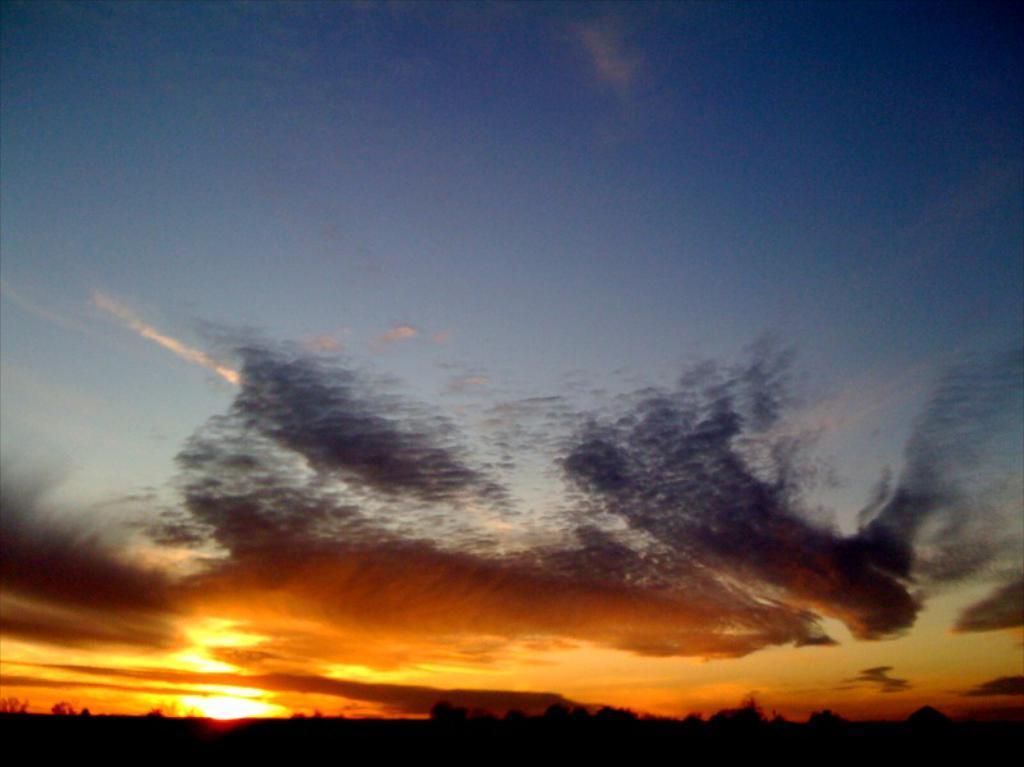Can you describe this image briefly? In this image there is the sky. The sky is colorful. In the bottom there is sun in the sky. At the bottom there are trees and it is dark. 